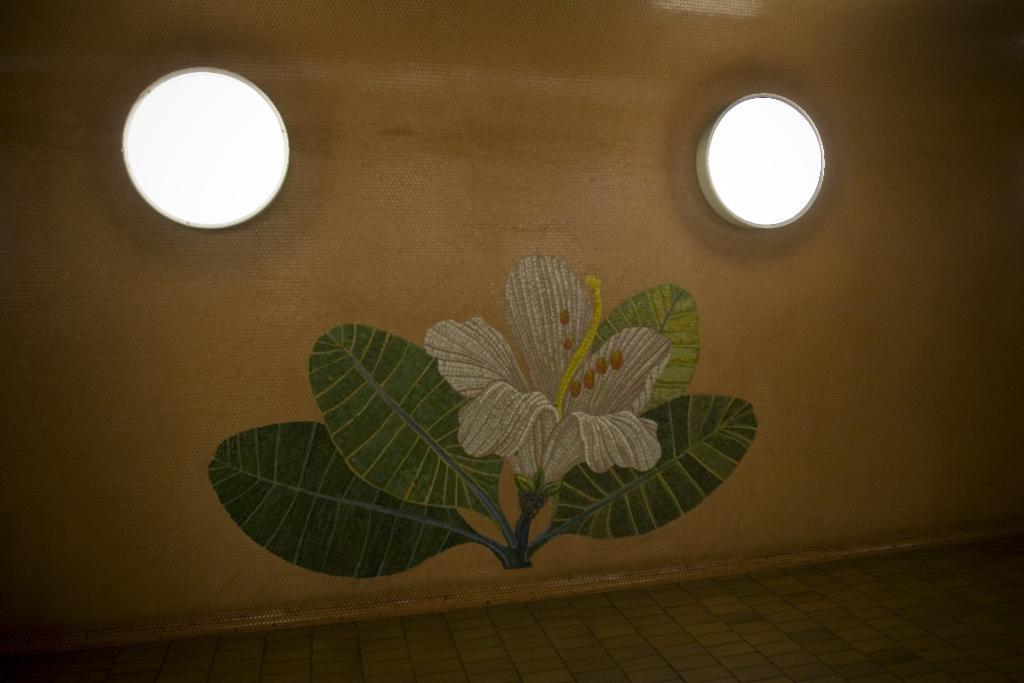Describe this image in one or two sentences. In this picture we can observe a wall which is in cream color. We can observe a painting on this wall. There is a flower and leaves. We can observe two lights fixed to this wall. 